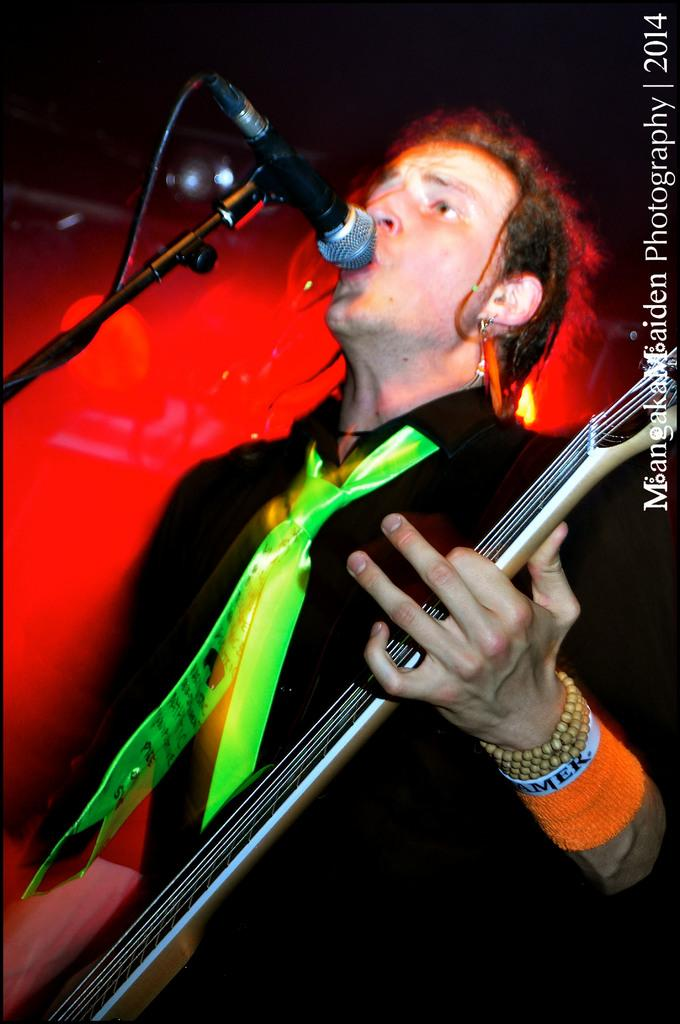What is the main subject in the foreground of the image? There is a man in the foreground of the image. What is the man doing in the image? The man is standing in front of a mic stand and holding a guitar. What is the man wearing in the image? The man is wearing a green tie. What can be seen in the background of the image? There is a red light in the background of the image. What type of beam is holding up the ceiling in the image? There is no mention of a ceiling or any beams in the image; it primarily features a man with a guitar and a mic stand. 